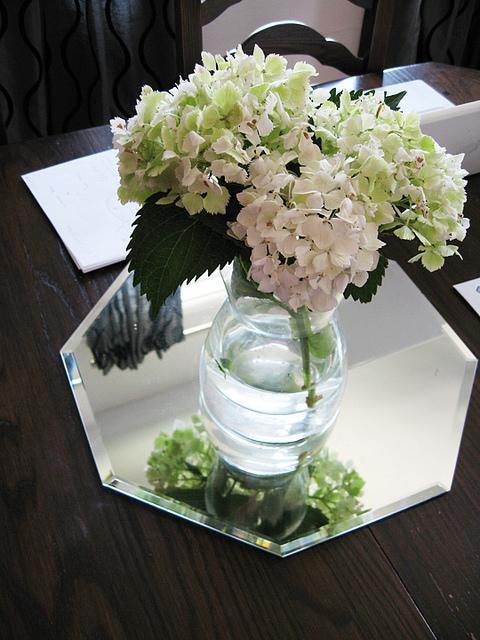How many chairs are there?
Give a very brief answer. 1. How many people are holding phone?
Give a very brief answer. 0. 